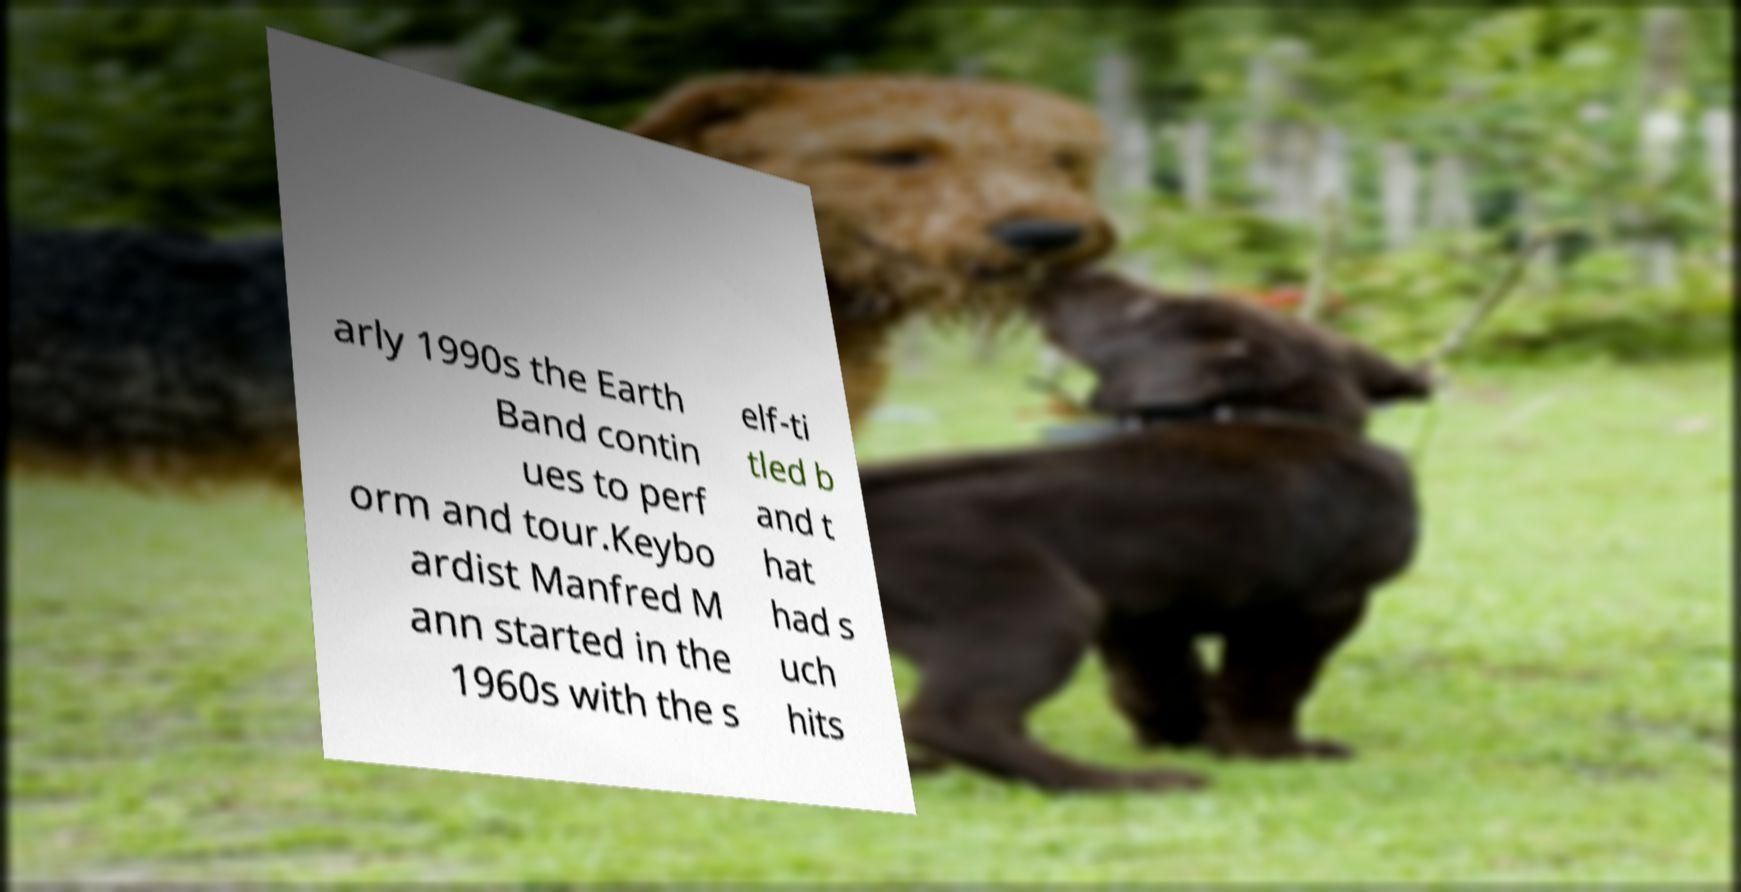Could you assist in decoding the text presented in this image and type it out clearly? arly 1990s the Earth Band contin ues to perf orm and tour.Keybo ardist Manfred M ann started in the 1960s with the s elf-ti tled b and t hat had s uch hits 